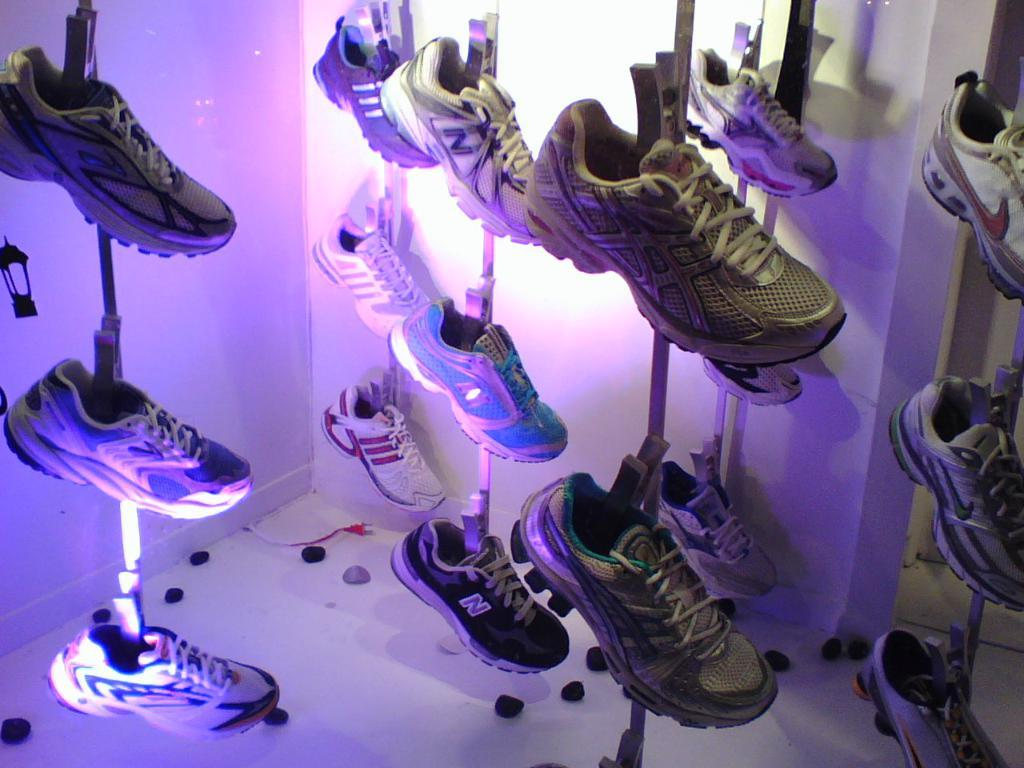What is hanging on the metal rod in the image? There are shoes hanged on a metal rod in the image. What can be seen on the floor in the image? There are objects on the floor in the image. What is visible in the background of the image? There is a wall in the background of the image. Can you hear the horn of a vehicle in the image? There is no mention of a vehicle or a horn in the image, so it cannot be heard. How many children are present in the image? There is no information about children in the image, so we cannot determine their presence or number. 